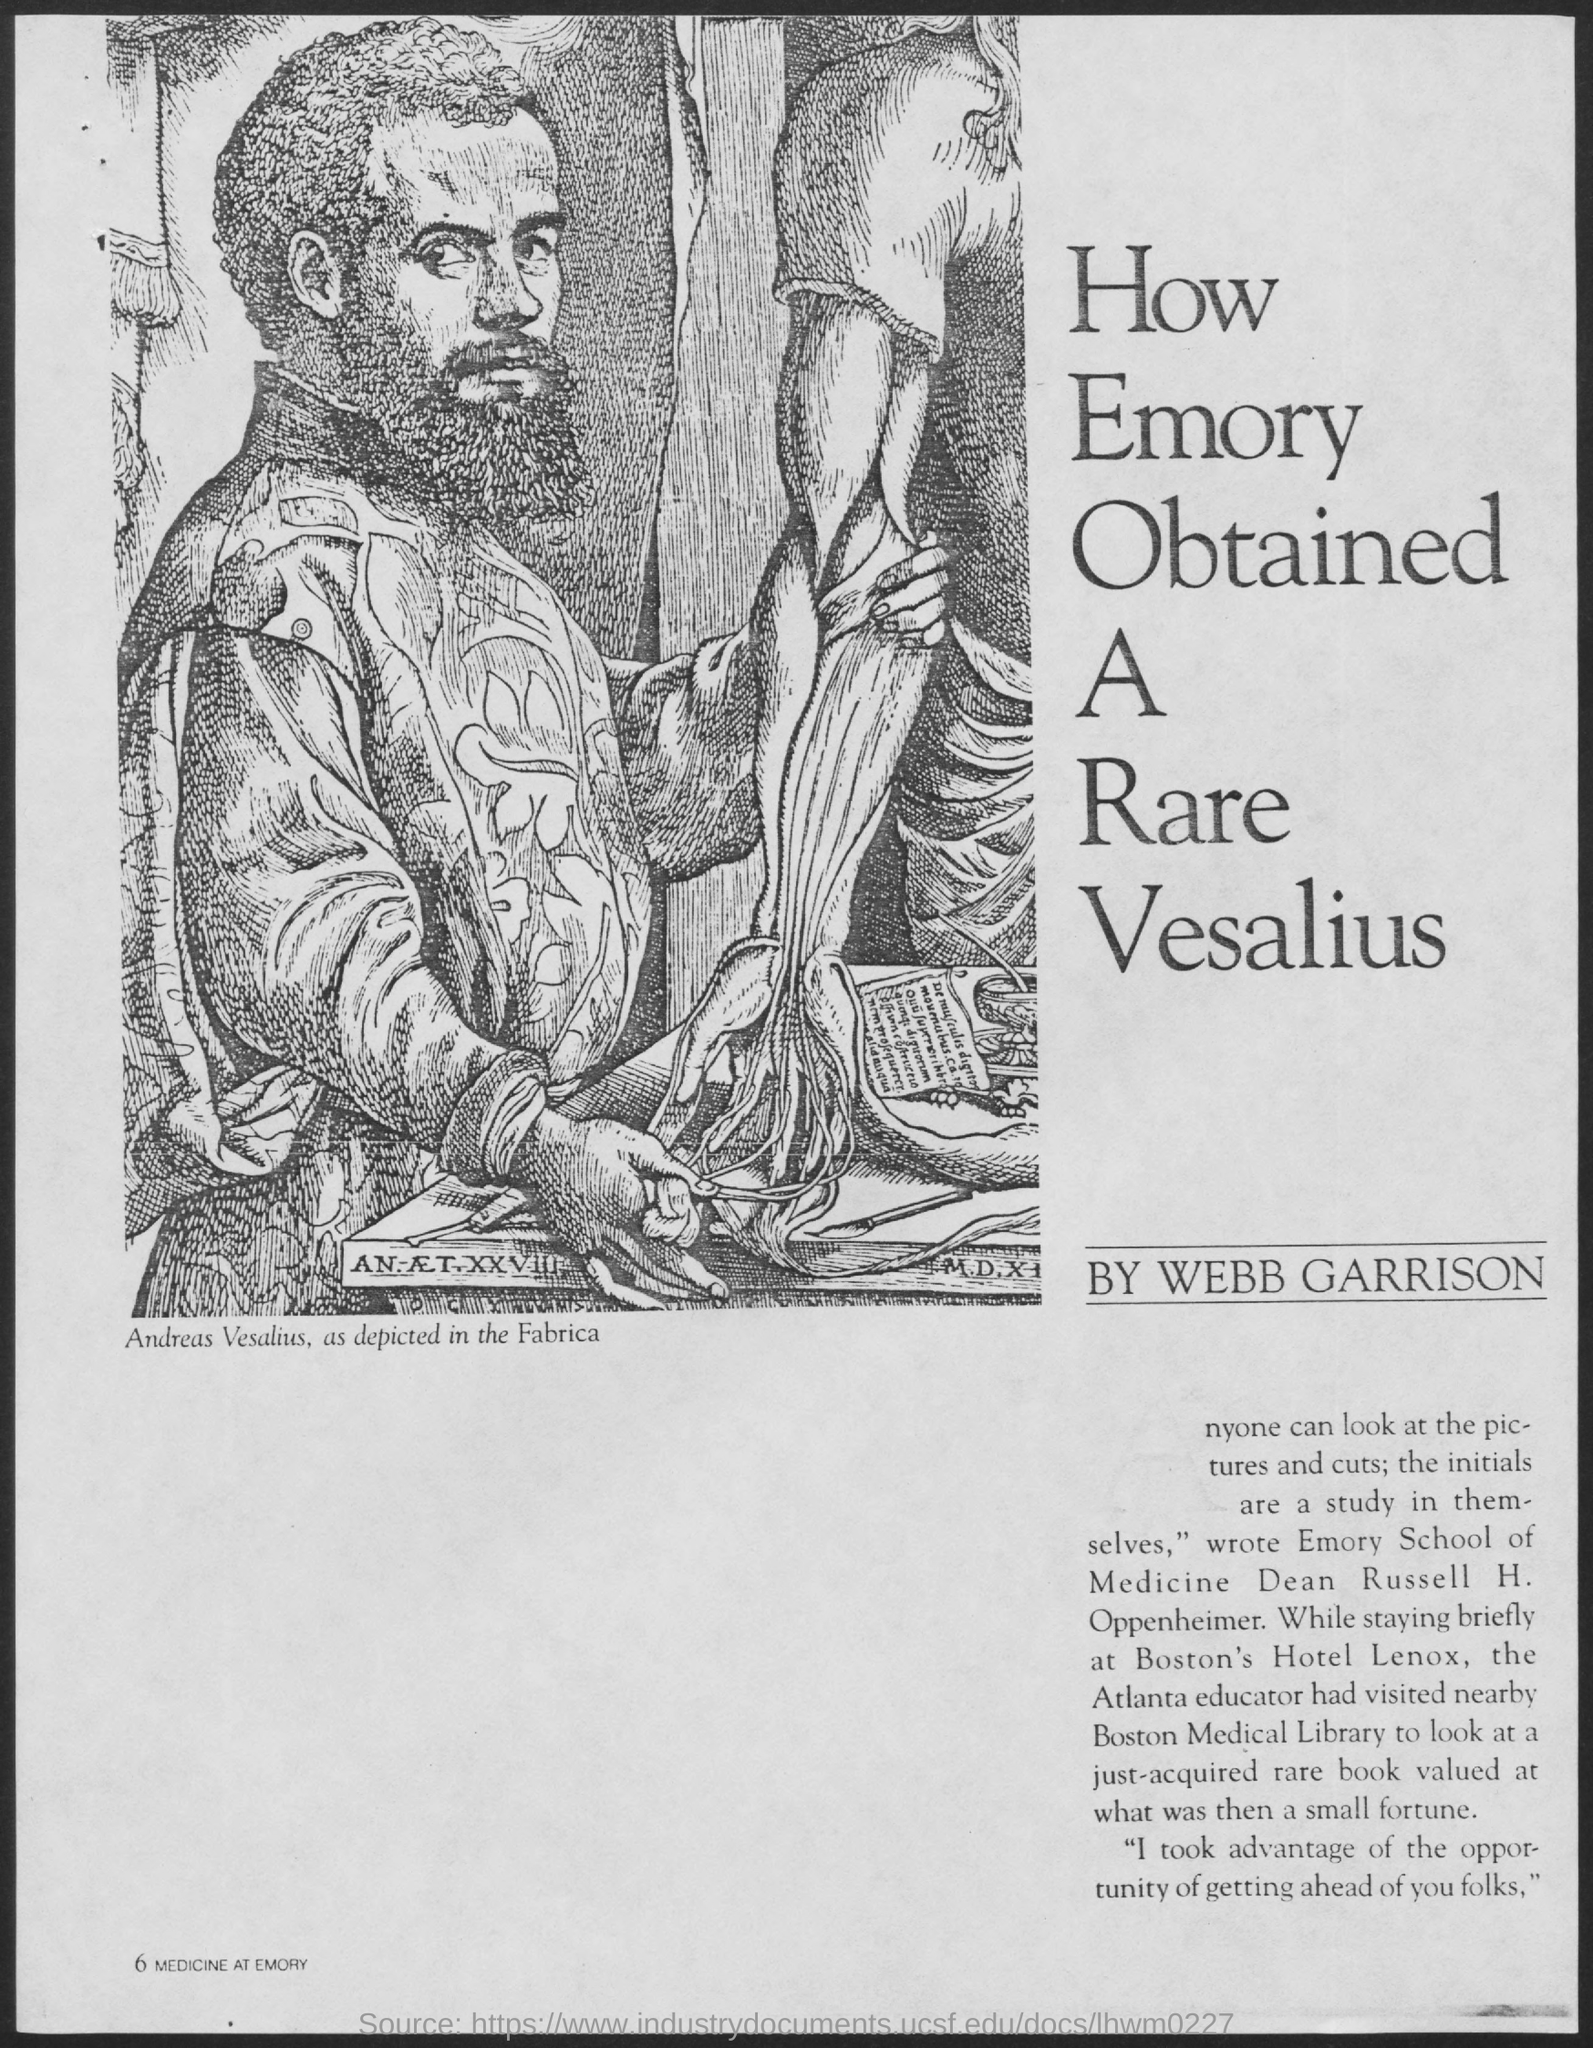What is the significance of Andreas Vesalius in medical history, depicted in this image? Andreas Vesalius, depicted here, is often called the founder of modern human anatomy. He is prominent for his book 'De Humani Corporis Fabrica', a groundbreaking work published in 1543 which detailed human anatomy with unprecedented accuracy and detail, challenging long-standing misconceptions. 